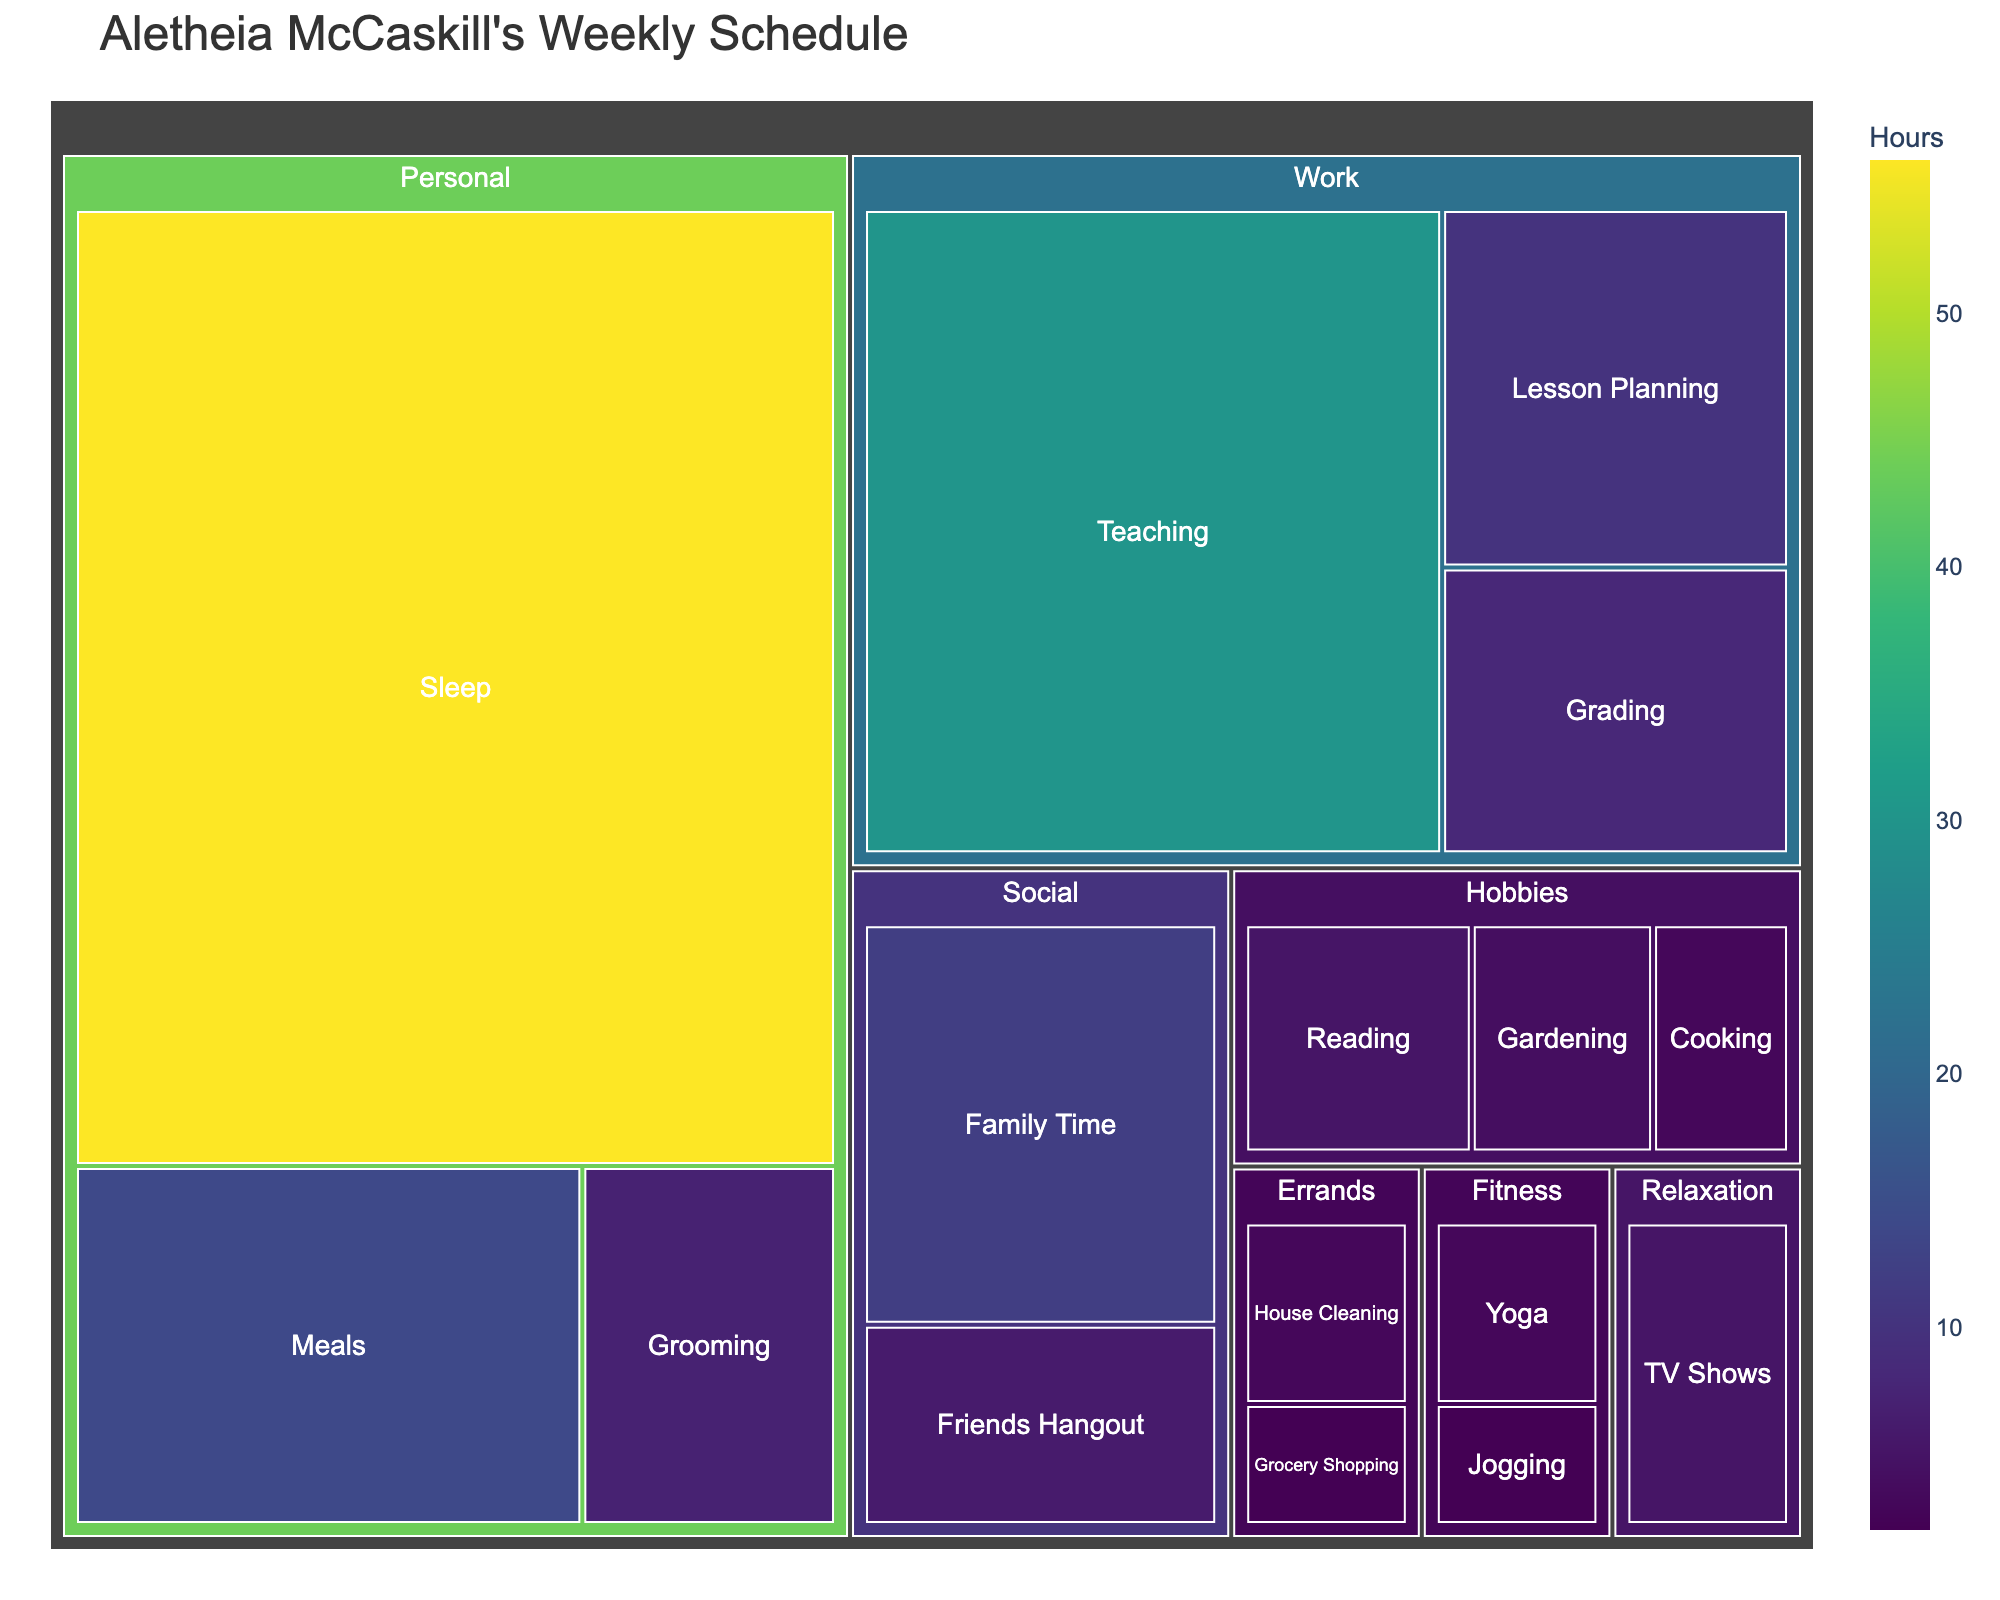What is the title of the figure? The title is usually found at the top of the figure. It gives a brief description of what the figure is about.
Answer: Aletheia McCaskill's Weekly Schedule Which activity takes up the most hours in Aletheia's week? From the figure, locate the largest section in the Treemap.
Answer: Sleep How many categories of activities are there? Count the number of distinct parent categories in the Treemap.
Answer: 6 What's the total number of hours spent on Personal activities? Add up the hours of all subcategories under the Personal category: 56 (Sleep) + 14 (Meals) + 7 (Grooming).
Answer: 77 Which category has the smallest total time allocation, and what is it? Compare the total hours of all categories. The one with the smallest sum is the answer.
Answer: Errands How does the time allocation for Family Time compare with Friends Hangout? Family Time has 12 hours and Friends Hangout has 6 hours. Compare these values.
Answer: Family Time is double that of Friends Hangout What is the combined time allocation for Hobbies and Fitness? Add up all the hours for subcategories under Hobbies and Fitness: 5 (Reading) + 4 (Gardening) + 3 (Cooking) + 3 (Yoga) + 2 (Jogging).
Answer: 17 Which subcategory under Work has the second highest time allocation? List the hours for all subcategories under Work and find the second highest value: 30 (Teaching), 10 (Lesson Planning), 8 (Grading).
Answer: Lesson Planning How does the time spent on TV Shows compare to time spent on Reading? TV Shows has 5 hours and Reading has 5 hours. Compare these values.
Answer: They are equal In the Social category, which subcategory has more time allocated and by how much? Compare the hours of the subcategories under Social: Family Time (12) and Friends Hangout (6). Calculate the difference.
Answer: Family Time has 6 more hours 